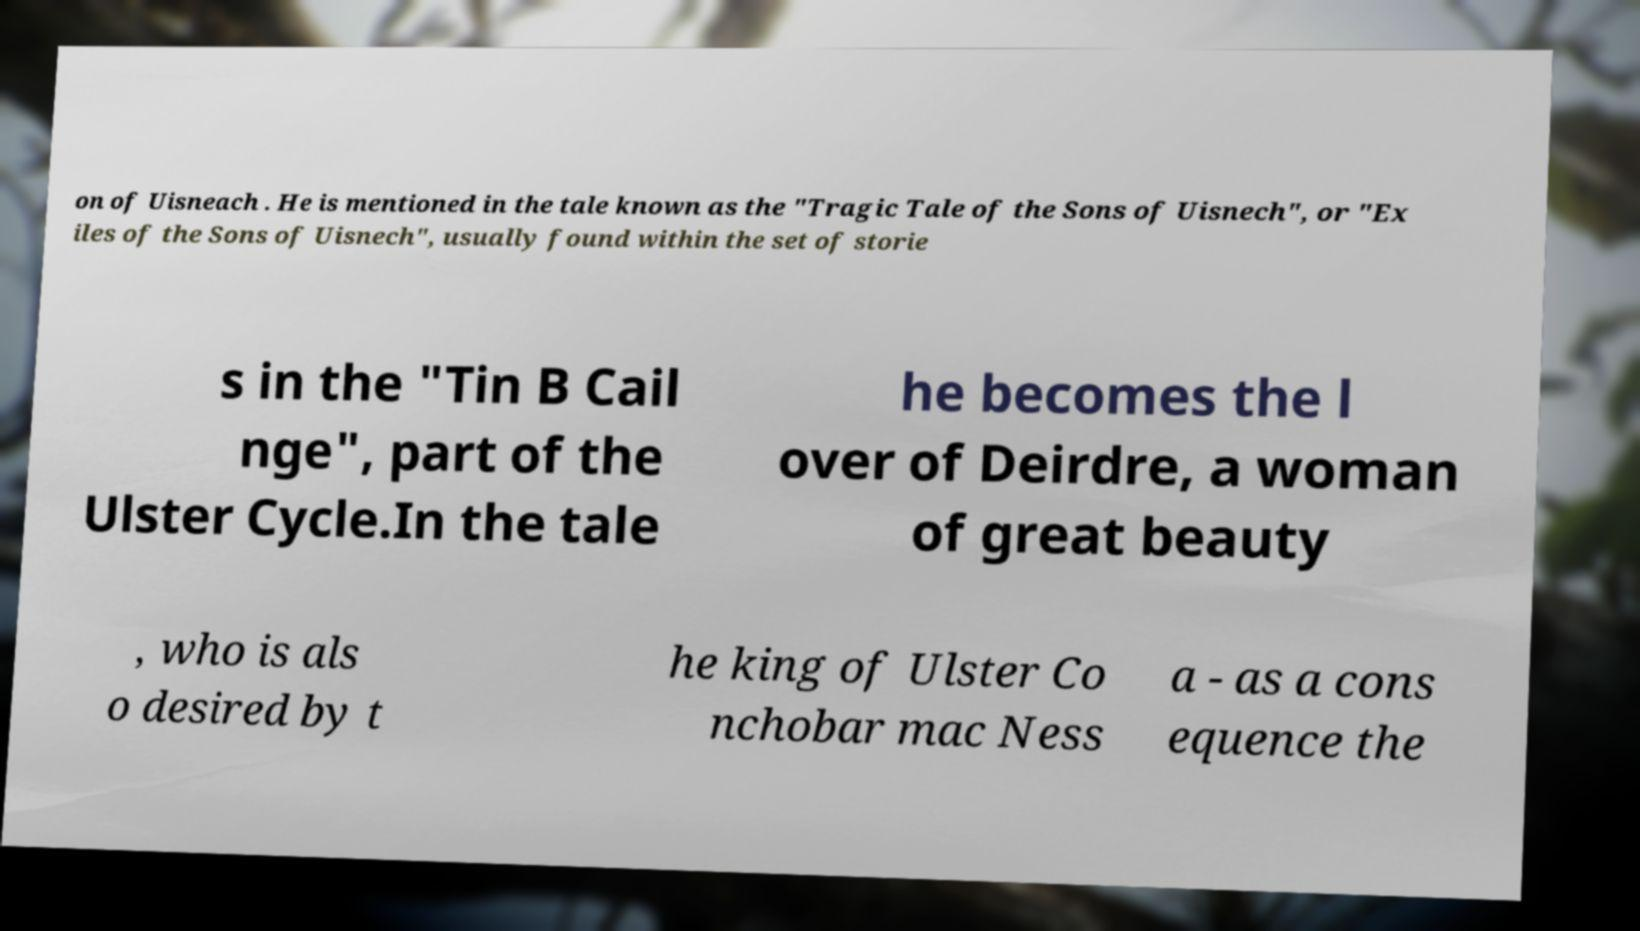Can you read and provide the text displayed in the image?This photo seems to have some interesting text. Can you extract and type it out for me? on of Uisneach . He is mentioned in the tale known as the "Tragic Tale of the Sons of Uisnech", or "Ex iles of the Sons of Uisnech", usually found within the set of storie s in the "Tin B Cail nge", part of the Ulster Cycle.In the tale he becomes the l over of Deirdre, a woman of great beauty , who is als o desired by t he king of Ulster Co nchobar mac Ness a - as a cons equence the 